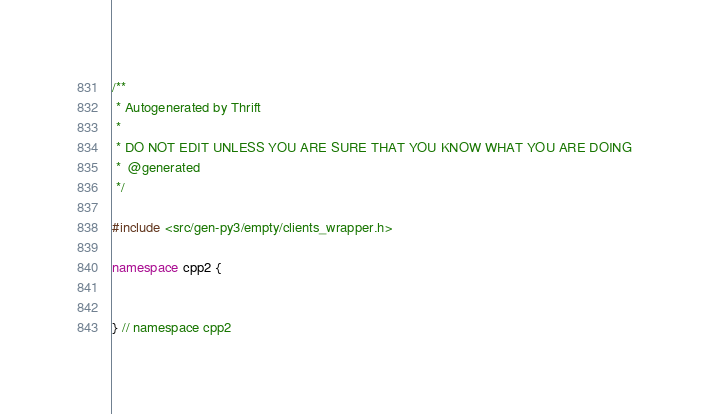Convert code to text. <code><loc_0><loc_0><loc_500><loc_500><_C++_>/**
 * Autogenerated by Thrift
 *
 * DO NOT EDIT UNLESS YOU ARE SURE THAT YOU KNOW WHAT YOU ARE DOING
 *  @generated
 */

#include <src/gen-py3/empty/clients_wrapper.h>

namespace cpp2 {


} // namespace cpp2
</code> 